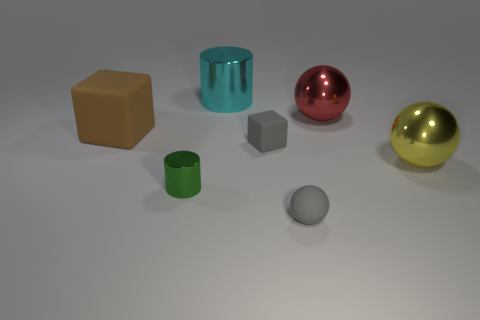Add 2 red objects. How many objects exist? 9 Subtract all spheres. How many objects are left? 4 Add 7 small green things. How many small green things exist? 8 Subtract 0 brown cylinders. How many objects are left? 7 Subtract all small metal things. Subtract all yellow metallic balls. How many objects are left? 5 Add 2 tiny rubber blocks. How many tiny rubber blocks are left? 3 